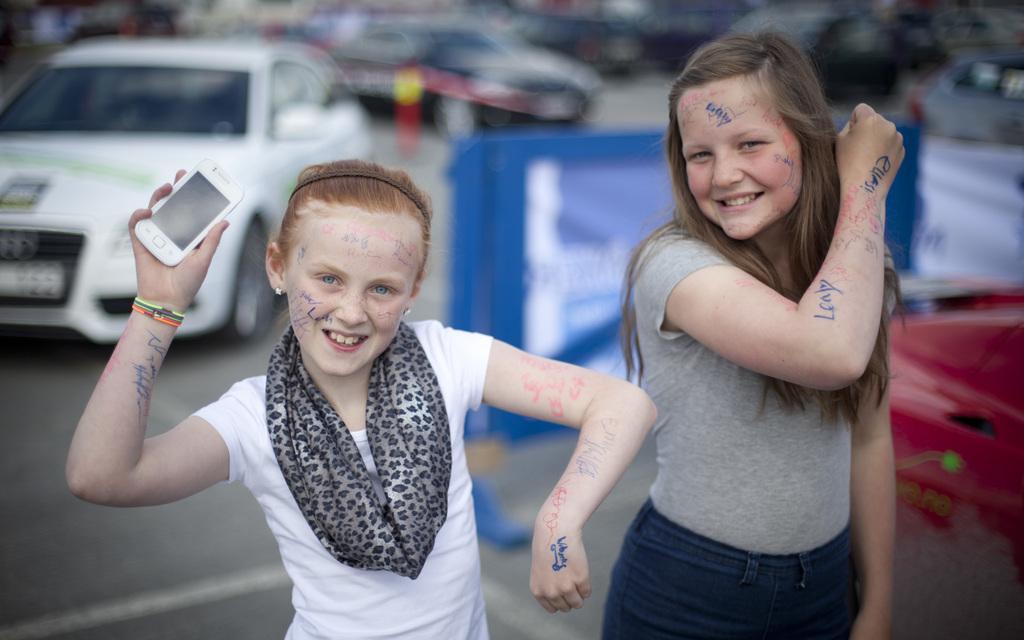Describe this image in one or two sentences. In the image in the center we can see two girls were standing and they were smiling,which we can see on their faces. And the left side girl is holding phone. In the background we can see few vehicles,banner,road and caution tape. 